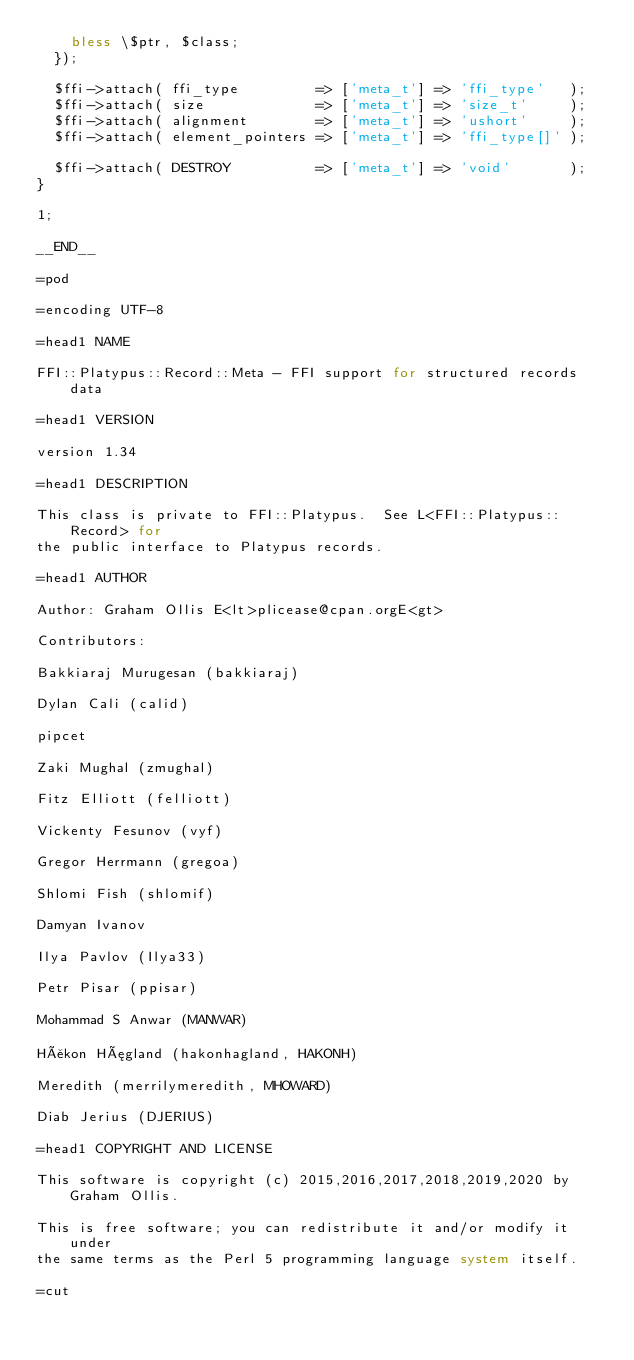<code> <loc_0><loc_0><loc_500><loc_500><_Perl_>    bless \$ptr, $class;
  });

  $ffi->attach( ffi_type         => ['meta_t'] => 'ffi_type'   );
  $ffi->attach( size             => ['meta_t'] => 'size_t'     );
  $ffi->attach( alignment        => ['meta_t'] => 'ushort'     );
  $ffi->attach( element_pointers => ['meta_t'] => 'ffi_type[]' );

  $ffi->attach( DESTROY          => ['meta_t'] => 'void'       );
}

1;

__END__

=pod

=encoding UTF-8

=head1 NAME

FFI::Platypus::Record::Meta - FFI support for structured records data

=head1 VERSION

version 1.34

=head1 DESCRIPTION

This class is private to FFI::Platypus.  See L<FFI::Platypus::Record> for
the public interface to Platypus records.

=head1 AUTHOR

Author: Graham Ollis E<lt>plicease@cpan.orgE<gt>

Contributors:

Bakkiaraj Murugesan (bakkiaraj)

Dylan Cali (calid)

pipcet

Zaki Mughal (zmughal)

Fitz Elliott (felliott)

Vickenty Fesunov (vyf)

Gregor Herrmann (gregoa)

Shlomi Fish (shlomif)

Damyan Ivanov

Ilya Pavlov (Ilya33)

Petr Pisar (ppisar)

Mohammad S Anwar (MANWAR)

Håkon Hægland (hakonhagland, HAKONH)

Meredith (merrilymeredith, MHOWARD)

Diab Jerius (DJERIUS)

=head1 COPYRIGHT AND LICENSE

This software is copyright (c) 2015,2016,2017,2018,2019,2020 by Graham Ollis.

This is free software; you can redistribute it and/or modify it under
the same terms as the Perl 5 programming language system itself.

=cut
</code> 